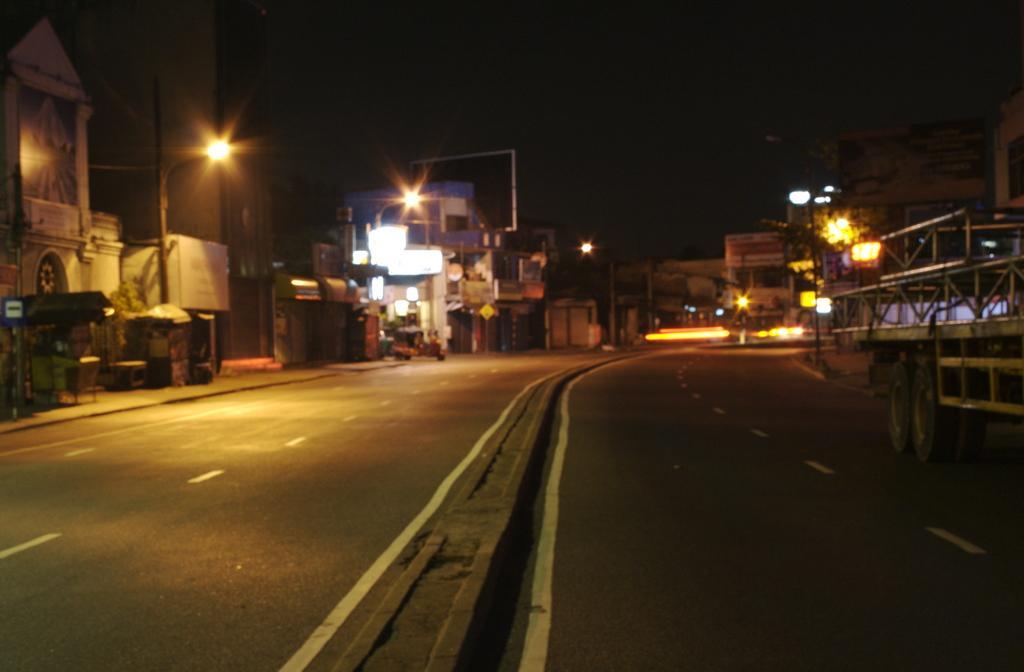Could you give a brief overview of what you see in this image? In the foreground of the picture it is road. On the right there is a construction. On the left there are buildings, street lights, bus stop, footpath, auto and other objects. In the center of the background there are buildings, street lights and sky. 